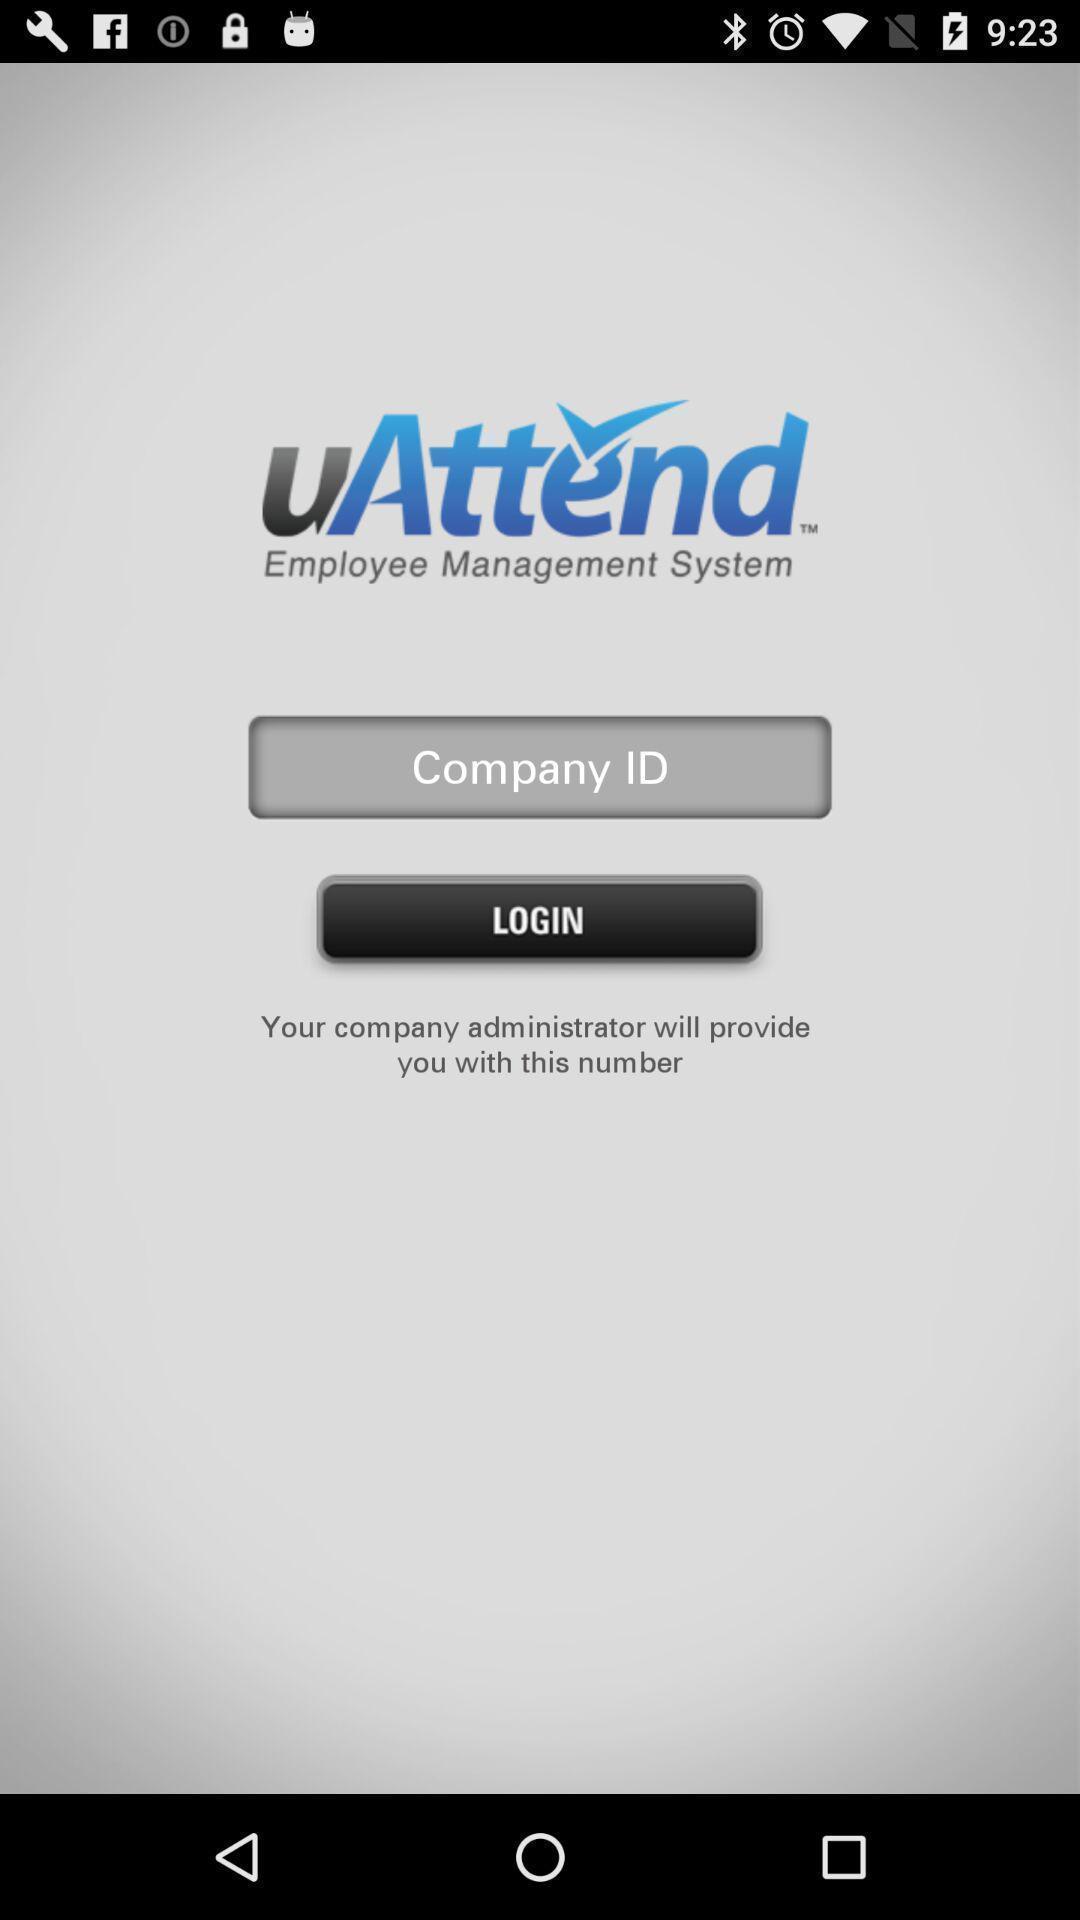Summarize the main components in this picture. Login page of management application. 